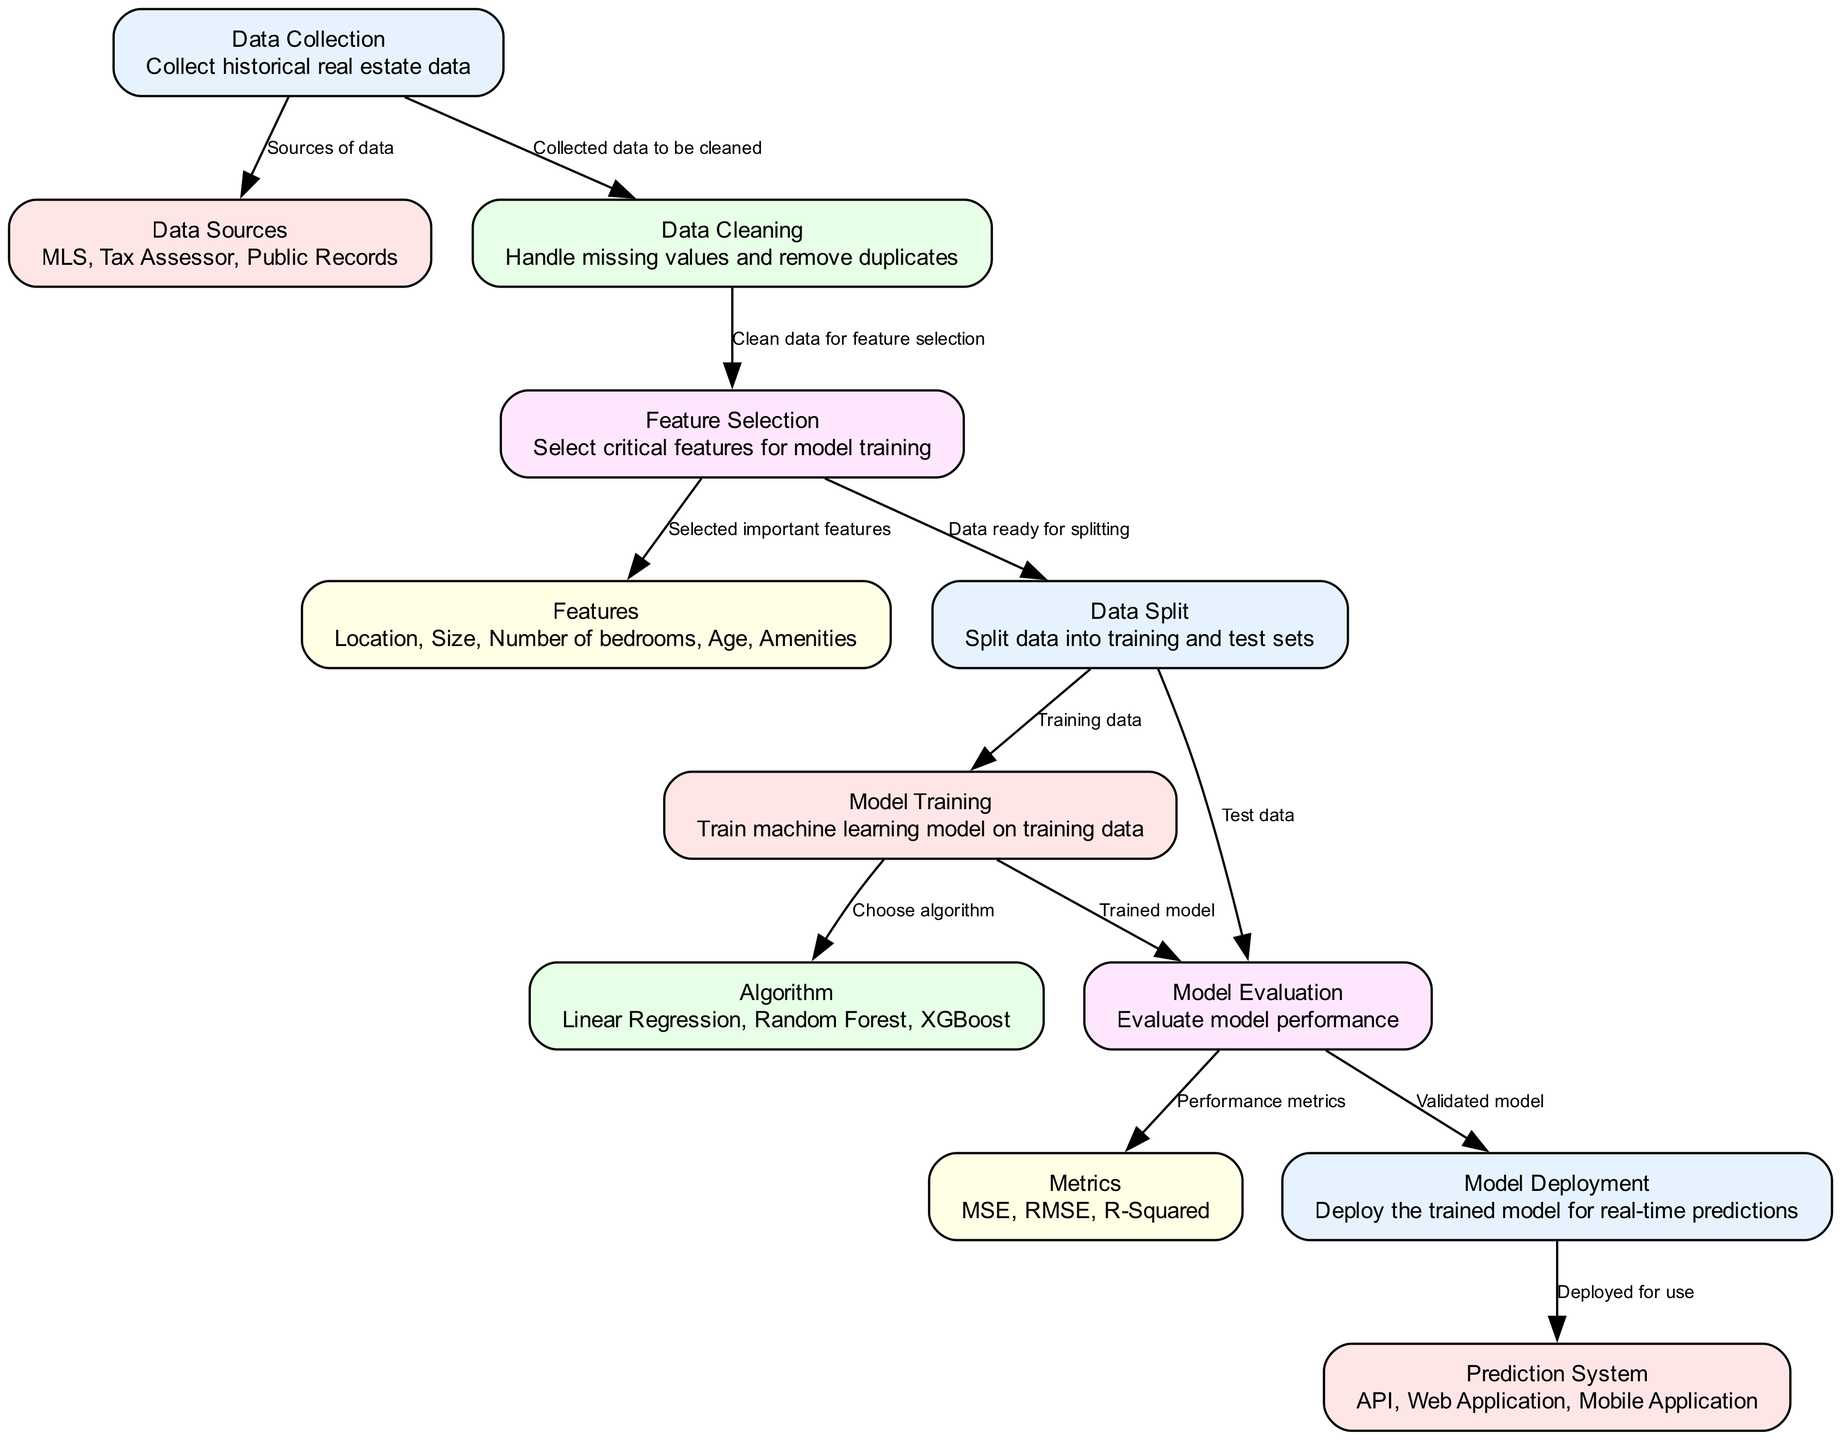What is the first step in the diagram? The first step in the diagram is "Data Collection," which involves gathering historical real estate data.
Answer: Data Collection How many nodes are present in the diagram? Counting all the nodes listed in the data section, there are a total of 12 nodes.
Answer: 12 Which node comes after "Data Cleaning"? After "Data Cleaning," the next node is "Feature Selection," where clean data is prepared to select important features for the model.
Answer: Feature Selection What are three algorithms mentioned in the diagram? The three algorithms specified in the "Algorithm" node are Linear Regression, Random Forest, and XGBoost.
Answer: Linear Regression, Random Forest, XGBoost What type of metrics is used for model evaluation? The metrics for model evaluation include Mean Squared Error, Root Mean Squared Error, and R-Squared, which assess the model's performance.
Answer: MSE, RMSE, R-Squared Which node is responsible for deploying the trained model? The node responsible for deploying the trained model is "Model Deployment," where the validated model is implemented for real-time predictions.
Answer: Model Deployment Describe the relationship between "Model Evaluation" and "Metrics." "Model Evaluation" leads to the "Metrics" node, where performance metrics like MSE, RMSE, and R-Squared are calculated to determine the model's effectiveness.
Answer: Performance metrics What happens after "Feature Selection"? After "Feature Selection," the data is split into training and test sets in the "Data Split" node, preparing it for model training and evaluation.
Answer: Data Split What is the role of the "Prediction System"? The "Prediction System" node indicates how the deployed model will be accessed or utilized, such as through an API, web application, or mobile application.
Answer: API, Web Application, Mobile Application 